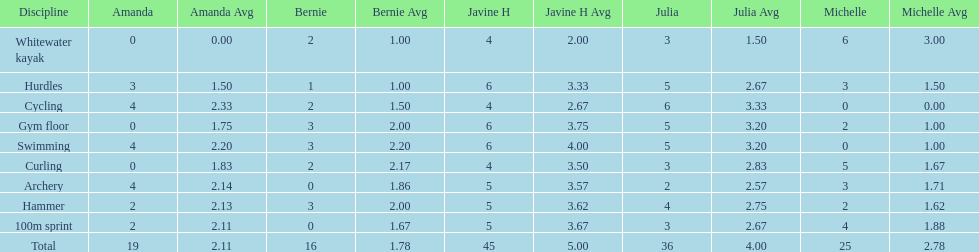What are the number of points bernie scored in hurdles? 1. 